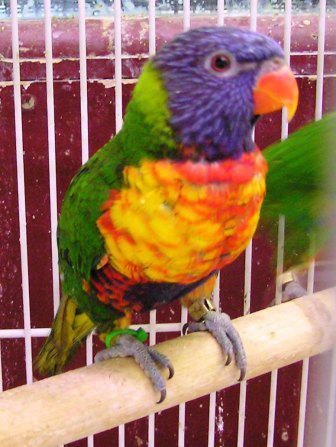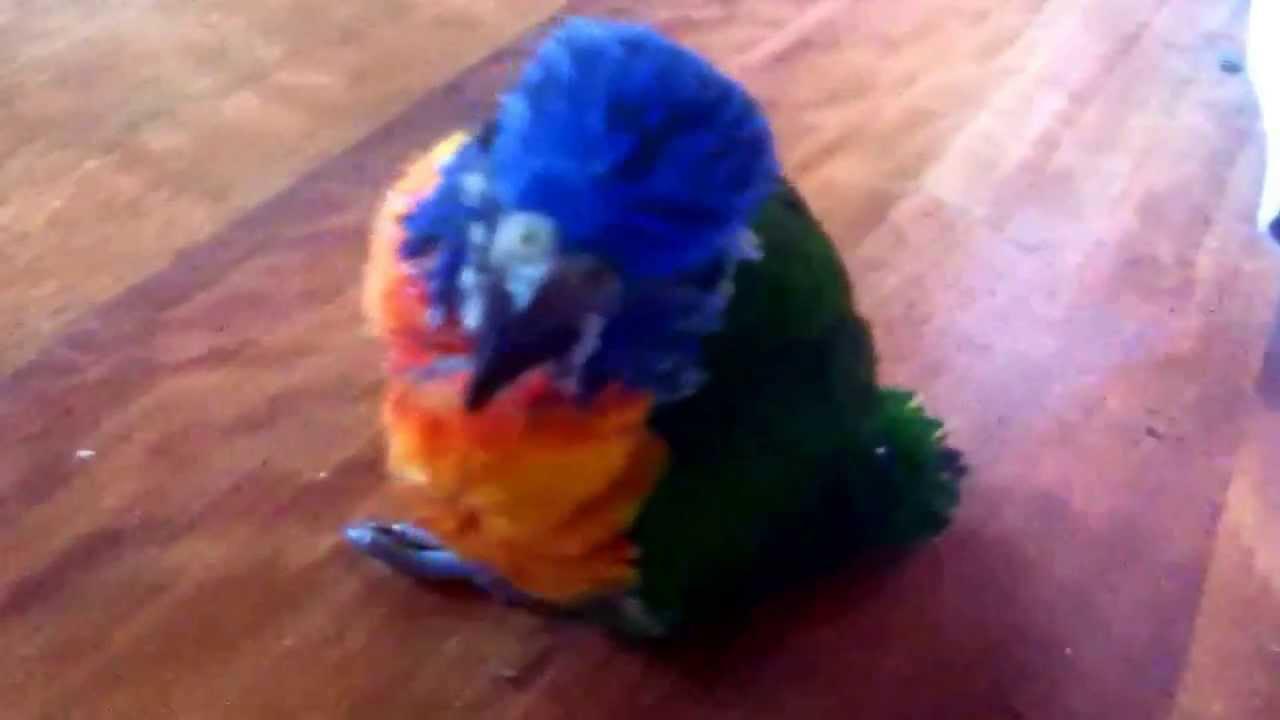The first image is the image on the left, the second image is the image on the right. Examine the images to the left and right. Is the description "In one of the images there are two colorful birds standing next to each other." accurate? Answer yes or no. No. The first image is the image on the left, the second image is the image on the right. Analyze the images presented: Is the assertion "One image features two multicolored parrots side-by-side." valid? Answer yes or no. No. 